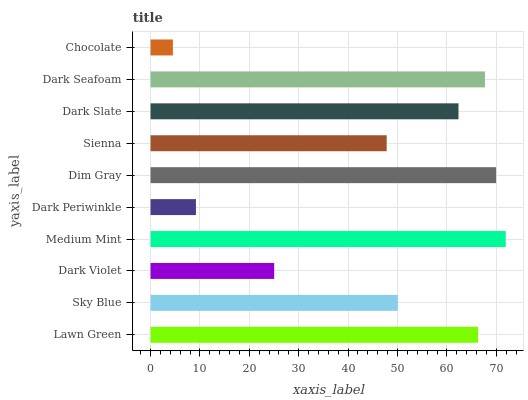Is Chocolate the minimum?
Answer yes or no. Yes. Is Medium Mint the maximum?
Answer yes or no. Yes. Is Sky Blue the minimum?
Answer yes or no. No. Is Sky Blue the maximum?
Answer yes or no. No. Is Lawn Green greater than Sky Blue?
Answer yes or no. Yes. Is Sky Blue less than Lawn Green?
Answer yes or no. Yes. Is Sky Blue greater than Lawn Green?
Answer yes or no. No. Is Lawn Green less than Sky Blue?
Answer yes or no. No. Is Dark Slate the high median?
Answer yes or no. Yes. Is Sky Blue the low median?
Answer yes or no. Yes. Is Medium Mint the high median?
Answer yes or no. No. Is Medium Mint the low median?
Answer yes or no. No. 